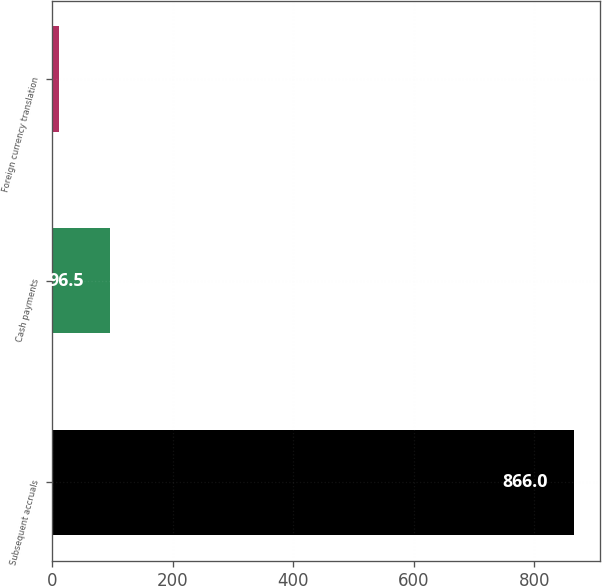Convert chart. <chart><loc_0><loc_0><loc_500><loc_500><bar_chart><fcel>Subsequent accruals<fcel>Cash payments<fcel>Foreign currency translation<nl><fcel>866<fcel>96.5<fcel>11<nl></chart> 